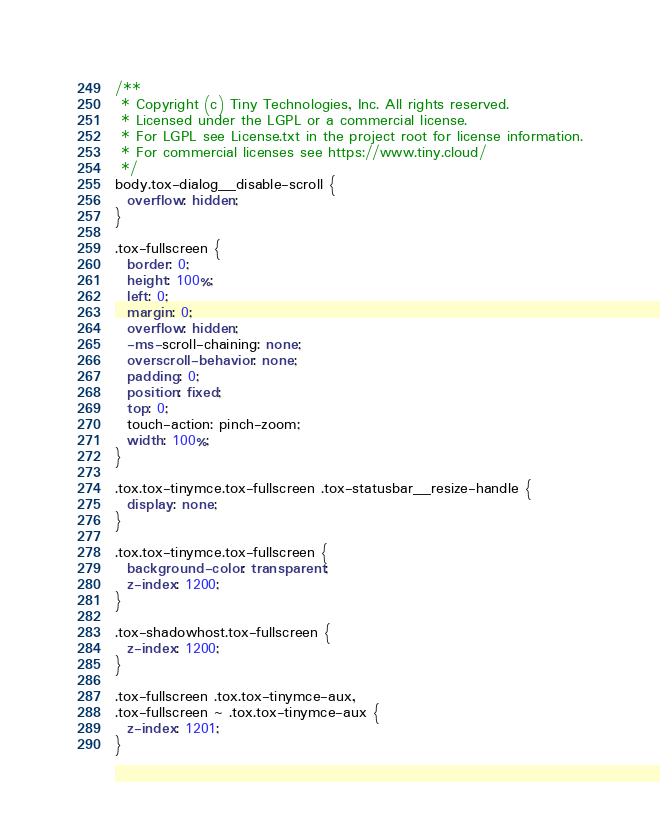<code> <loc_0><loc_0><loc_500><loc_500><_CSS_>/**
 * Copyright (c) Tiny Technologies, Inc. All rights reserved.
 * Licensed under the LGPL or a commercial license.
 * For LGPL see License.txt in the project root for license information.
 * For commercial licenses see https://www.tiny.cloud/
 */
body.tox-dialog__disable-scroll {
  overflow: hidden;
}

.tox-fullscreen {
  border: 0;
  height: 100%;
  left: 0;
  margin: 0;
  overflow: hidden;
  -ms-scroll-chaining: none;
  overscroll-behavior: none;
  padding: 0;
  position: fixed;
  top: 0;
  touch-action: pinch-zoom;
  width: 100%;
}

.tox.tox-tinymce.tox-fullscreen .tox-statusbar__resize-handle {
  display: none;
}

.tox.tox-tinymce.tox-fullscreen {
  background-color: transparent;
  z-index: 1200;
}

.tox-shadowhost.tox-fullscreen {
  z-index: 1200;
}

.tox-fullscreen .tox.tox-tinymce-aux,
.tox-fullscreen ~ .tox.tox-tinymce-aux {
  z-index: 1201;
}</code> 